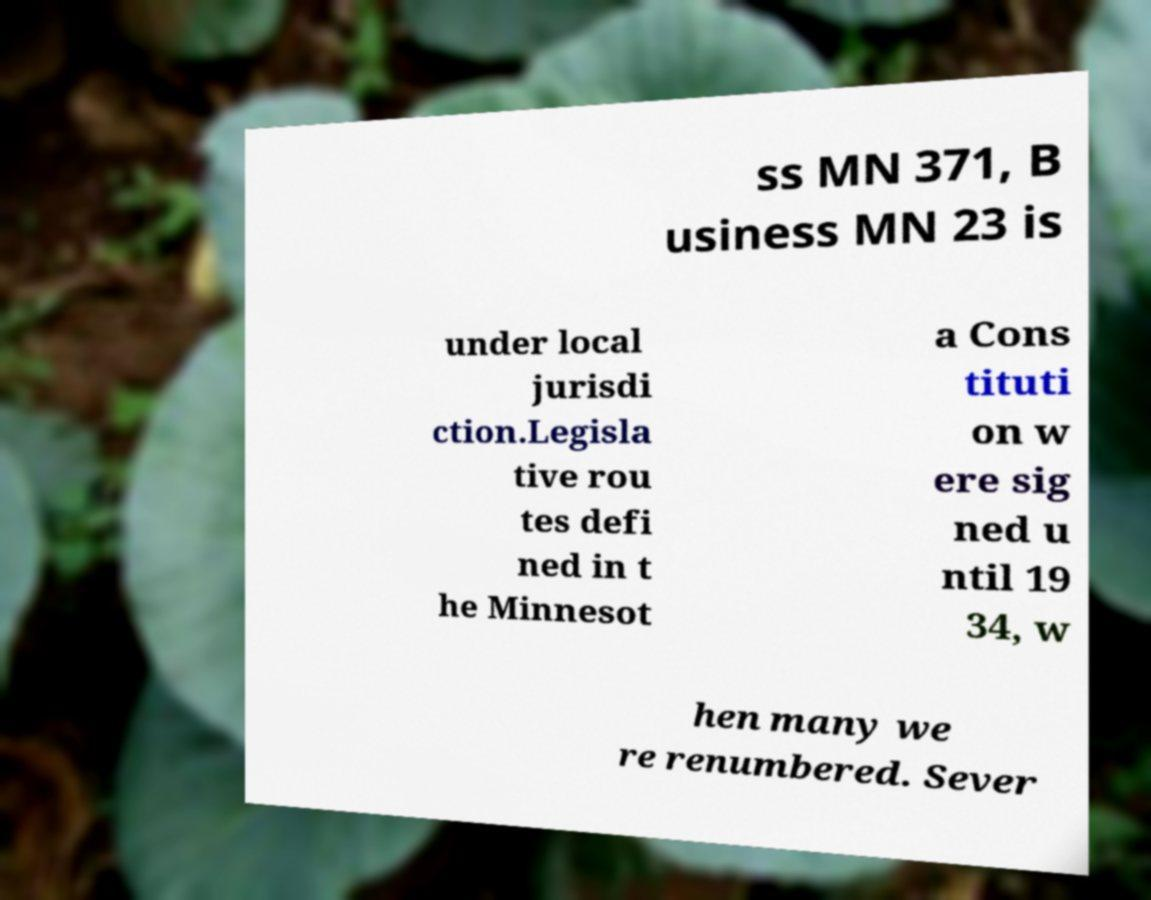What messages or text are displayed in this image? I need them in a readable, typed format. ss MN 371, B usiness MN 23 is under local jurisdi ction.Legisla tive rou tes defi ned in t he Minnesot a Cons tituti on w ere sig ned u ntil 19 34, w hen many we re renumbered. Sever 